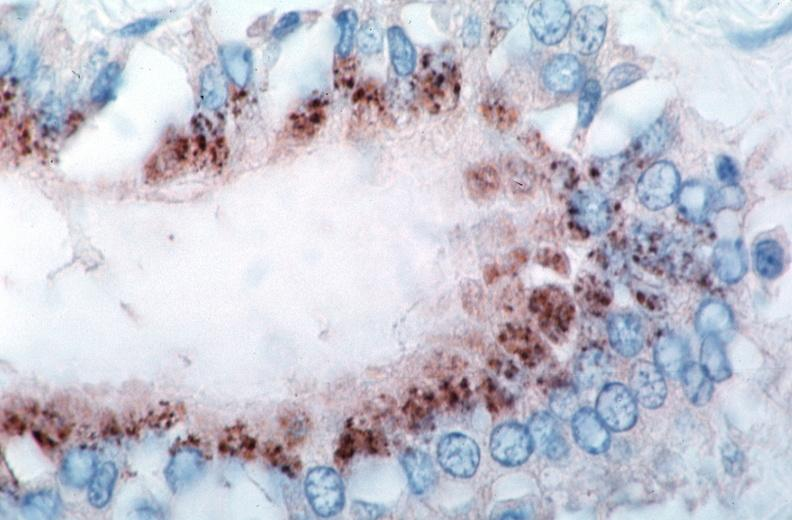what is vasculitis , rocky mountain spotted?
Answer the question using a single word or phrase. Fever immunoperoxidase staining vessels for rickettsia rickettsii 